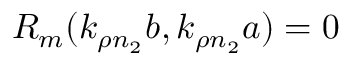<formula> <loc_0><loc_0><loc_500><loc_500>R _ { m } ( k _ { \rho n _ { 2 } } b , k _ { \rho n _ { 2 } } a ) = 0</formula> 